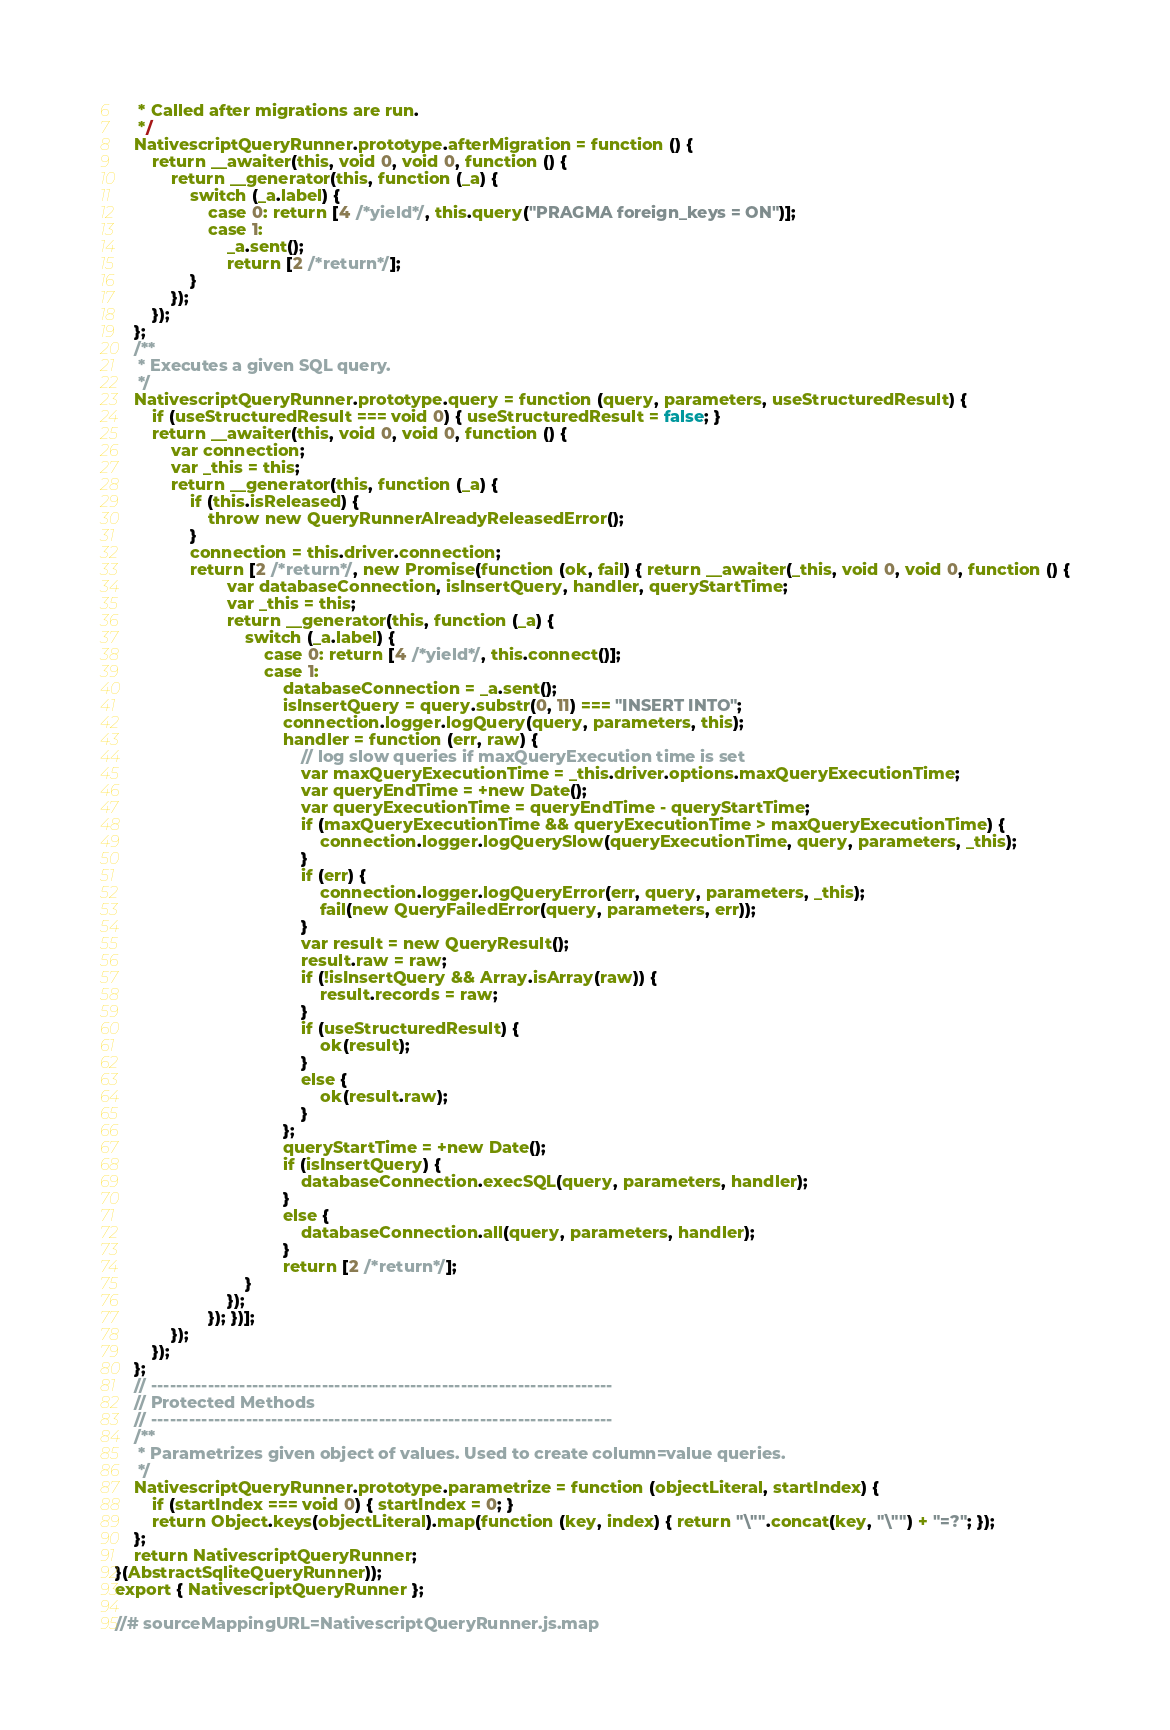<code> <loc_0><loc_0><loc_500><loc_500><_JavaScript_>     * Called after migrations are run.
     */
    NativescriptQueryRunner.prototype.afterMigration = function () {
        return __awaiter(this, void 0, void 0, function () {
            return __generator(this, function (_a) {
                switch (_a.label) {
                    case 0: return [4 /*yield*/, this.query("PRAGMA foreign_keys = ON")];
                    case 1:
                        _a.sent();
                        return [2 /*return*/];
                }
            });
        });
    };
    /**
     * Executes a given SQL query.
     */
    NativescriptQueryRunner.prototype.query = function (query, parameters, useStructuredResult) {
        if (useStructuredResult === void 0) { useStructuredResult = false; }
        return __awaiter(this, void 0, void 0, function () {
            var connection;
            var _this = this;
            return __generator(this, function (_a) {
                if (this.isReleased) {
                    throw new QueryRunnerAlreadyReleasedError();
                }
                connection = this.driver.connection;
                return [2 /*return*/, new Promise(function (ok, fail) { return __awaiter(_this, void 0, void 0, function () {
                        var databaseConnection, isInsertQuery, handler, queryStartTime;
                        var _this = this;
                        return __generator(this, function (_a) {
                            switch (_a.label) {
                                case 0: return [4 /*yield*/, this.connect()];
                                case 1:
                                    databaseConnection = _a.sent();
                                    isInsertQuery = query.substr(0, 11) === "INSERT INTO";
                                    connection.logger.logQuery(query, parameters, this);
                                    handler = function (err, raw) {
                                        // log slow queries if maxQueryExecution time is set
                                        var maxQueryExecutionTime = _this.driver.options.maxQueryExecutionTime;
                                        var queryEndTime = +new Date();
                                        var queryExecutionTime = queryEndTime - queryStartTime;
                                        if (maxQueryExecutionTime && queryExecutionTime > maxQueryExecutionTime) {
                                            connection.logger.logQuerySlow(queryExecutionTime, query, parameters, _this);
                                        }
                                        if (err) {
                                            connection.logger.logQueryError(err, query, parameters, _this);
                                            fail(new QueryFailedError(query, parameters, err));
                                        }
                                        var result = new QueryResult();
                                        result.raw = raw;
                                        if (!isInsertQuery && Array.isArray(raw)) {
                                            result.records = raw;
                                        }
                                        if (useStructuredResult) {
                                            ok(result);
                                        }
                                        else {
                                            ok(result.raw);
                                        }
                                    };
                                    queryStartTime = +new Date();
                                    if (isInsertQuery) {
                                        databaseConnection.execSQL(query, parameters, handler);
                                    }
                                    else {
                                        databaseConnection.all(query, parameters, handler);
                                    }
                                    return [2 /*return*/];
                            }
                        });
                    }); })];
            });
        });
    };
    // -------------------------------------------------------------------------
    // Protected Methods
    // -------------------------------------------------------------------------
    /**
     * Parametrizes given object of values. Used to create column=value queries.
     */
    NativescriptQueryRunner.prototype.parametrize = function (objectLiteral, startIndex) {
        if (startIndex === void 0) { startIndex = 0; }
        return Object.keys(objectLiteral).map(function (key, index) { return "\"".concat(key, "\"") + "=?"; });
    };
    return NativescriptQueryRunner;
}(AbstractSqliteQueryRunner));
export { NativescriptQueryRunner };

//# sourceMappingURL=NativescriptQueryRunner.js.map
</code> 